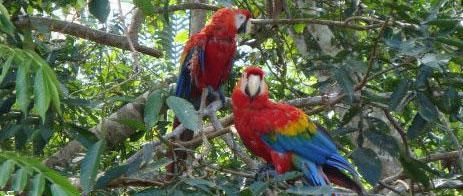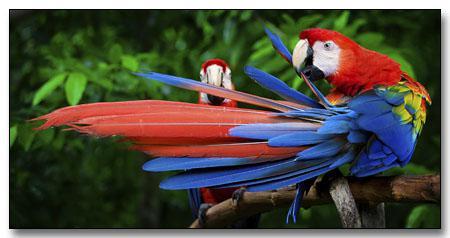The first image is the image on the left, the second image is the image on the right. Examine the images to the left and right. Is the description "A total of three parrots are shown, and the left image contains two red-headed parrots." accurate? Answer yes or no. No. The first image is the image on the left, the second image is the image on the right. Assess this claim about the two images: "There is exactly one parrot in the right image with a red head.". Correct or not? Answer yes or no. No. 